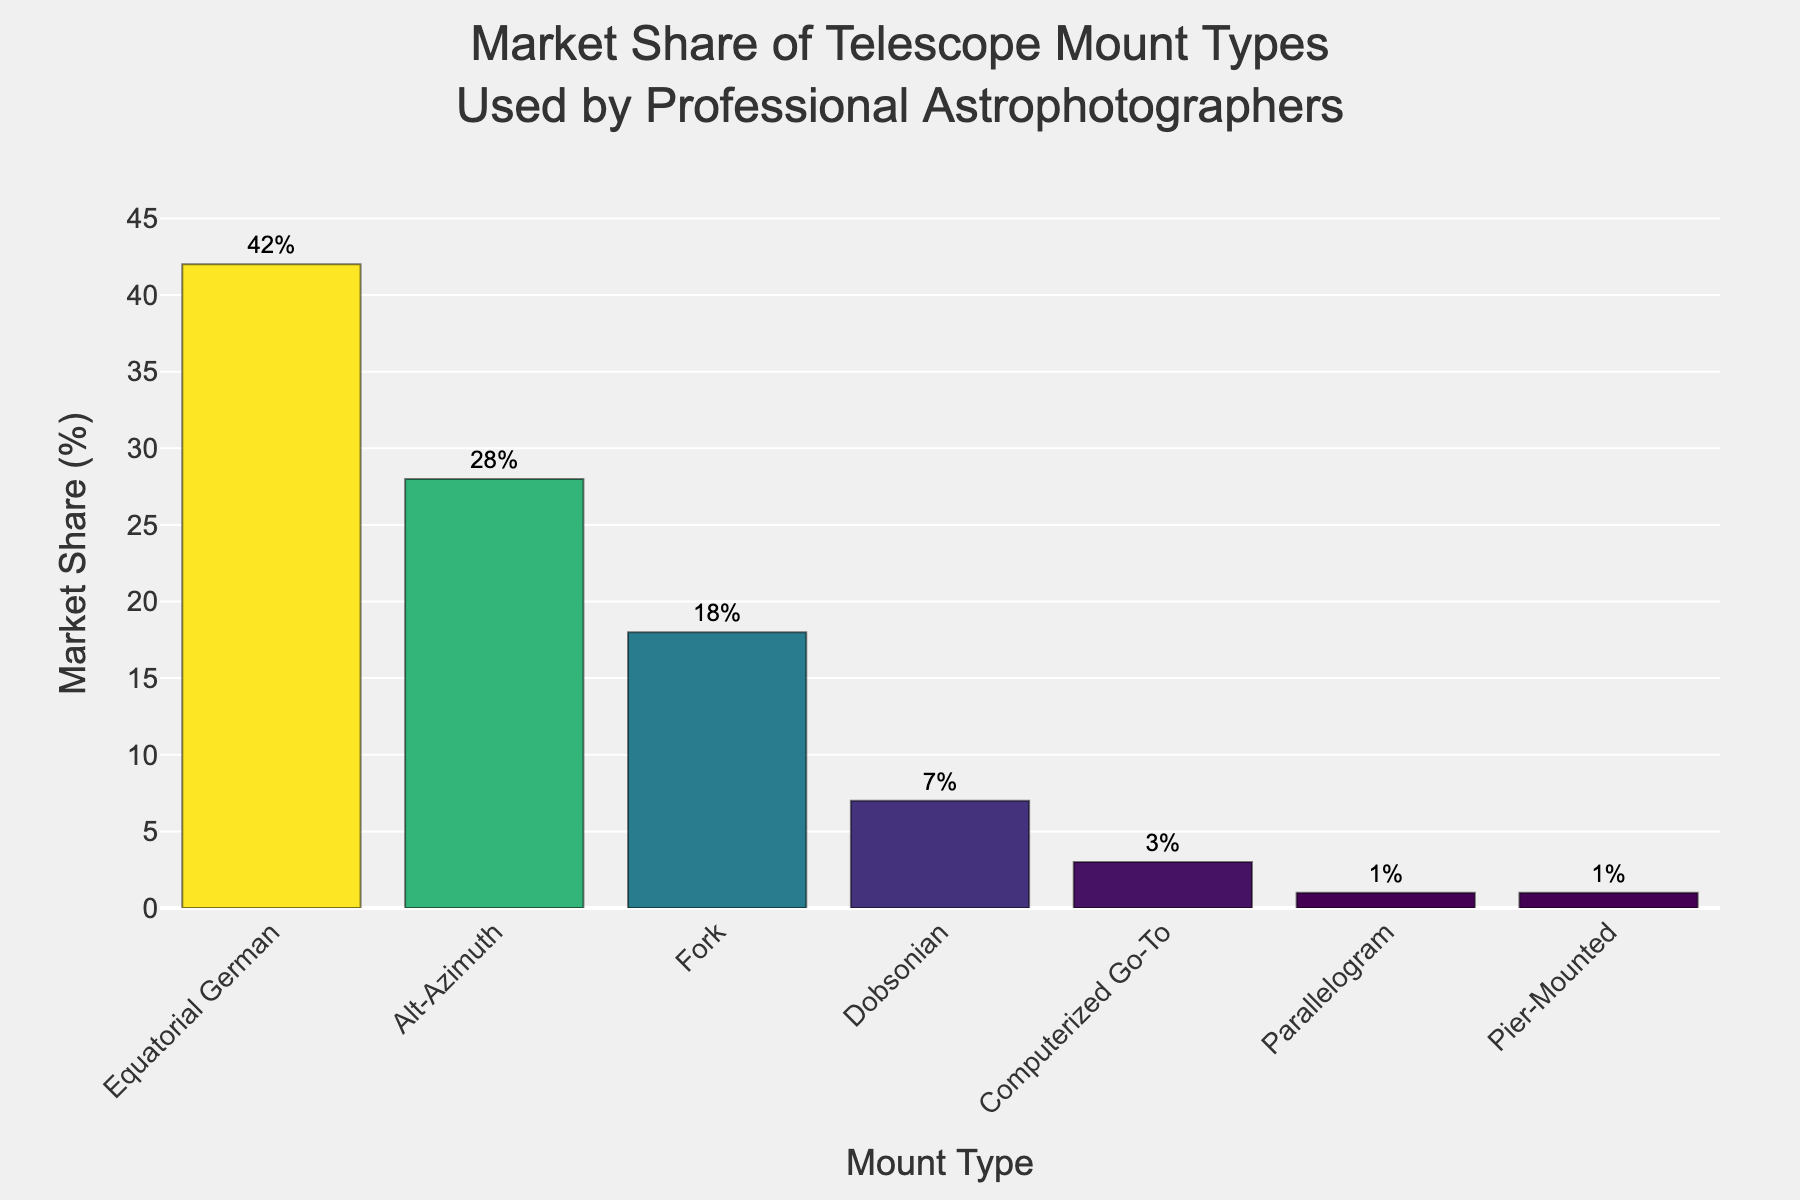What is the mount type with the highest market share? The mount type with the highest market share is shown as the tallest bar, representing the largest percentage. The tallest bar corresponds to "Equatorial German" with a market share of 42%.
Answer: Equatorial German Which mount types have a market share greater than 20%? To find the mount types with a market share greater than 20%, look at the bars that are above the 20% mark on the y-axis. The bars for "Equatorial German" (42%) and "Alt-Azimuth" (28%) surpass this value.
Answer: Equatorial German and Alt-Azimuth How much more market share does Equatorial German have compared to Alt-Azimuth? To find the difference in market share between these two mount types, subtract the market share value of "Alt-Azimuth" from that of "Equatorial German": 42% - 28% = 14%.
Answer: 14% What is the total market share of mount types that fall under 10%? Sum up the market shares of the mount types with less than 10%: Dobsonian (7%), Computerized Go-To (3%), Parallelogram (1%), and Pier-Mounted (1%). 7% + 3% + 1% + 1% = 12%.
Answer: 12% Which mount type has the least market share, and what is it? The mount type with the least market share is represented by the shortest bar. Both "Parallelogram" and "Pier-Mounted" have the shortest bars, each with a market share of 1%.
Answer: Parallelogram and Pier-Mounted, 1% What is the average market share of all mount types? Calculate the sum of the market share values for all mount types and then divide by the number of mount types. The sum is 42 + 28 + 18 + 7 + 3 + 1 + 1 = 100. There are 7 mount types, so the average market share is 100 / 7 ≈ 14.29%.
Answer: 14.29% How does the market share of Fork mounts compare to that of Dobsonian mounts? Compare the height of the bars representing Fork mounts (18%) and Dobsonian mounts (7%). The Fork mount has a higher market share by 18% - 7% = 11%.
Answer: Fork mounts have an 11% higher market share than Dobsonian mounts What percentage of the market do the three most popular mount types occupy? Sum the market shares of the top three mount types: Equatorial German (42%), Alt-Azimuth (28%), and Fork (18%). 42% + 28% + 18% = 88%.
Answer: 88% Which two mount types have market shares that add up to exactly 15%? Look for two bars whose combined heights equal 15%. "Computerized Go-To" (3%) and "Pier-Mounted" (1%) combined with another type might not total 15%. Instead, consider "Dobsonian" (7%) and "Alt-Azimuth" (28%) individually with no direct match. There is no exact combination of two types that precisely sum up to 15%.
Answer: None 